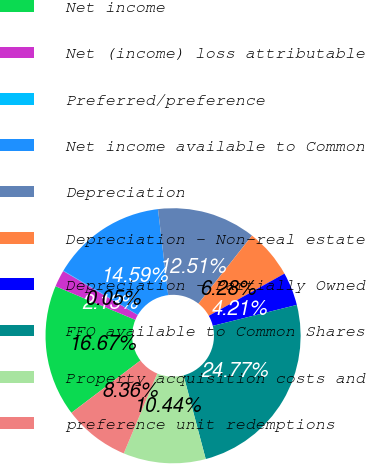Convert chart. <chart><loc_0><loc_0><loc_500><loc_500><pie_chart><fcel>Net income<fcel>Net (income) loss attributable<fcel>Preferred/preference<fcel>Net income available to Common<fcel>Depreciation<fcel>Depreciation - Non-real estate<fcel>Depreciation - Partially Owned<fcel>FFO available to Common Shares<fcel>Property acquisition costs and<fcel>preference unit redemptions<nl><fcel>16.67%<fcel>2.13%<fcel>0.05%<fcel>14.59%<fcel>12.51%<fcel>6.28%<fcel>4.21%<fcel>24.77%<fcel>10.44%<fcel>8.36%<nl></chart> 